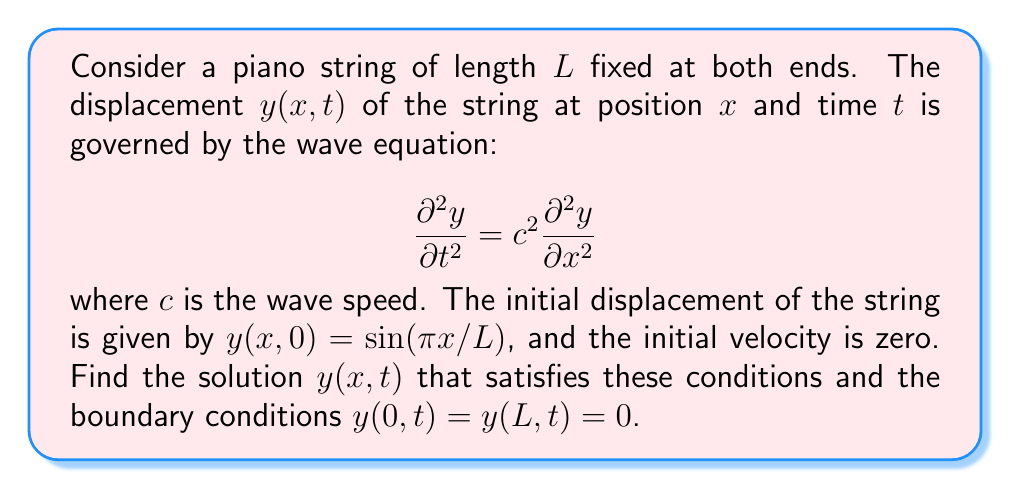Solve this math problem. 1) We start by assuming a solution of the form:
   $$y(x,t) = X(x)T(t)$$

2) Substituting this into the wave equation:
   $$X(x)T''(t) = c^2X''(x)T(t)$$

3) Separating variables:
   $$\frac{T''(t)}{c^2T(t)} = \frac{X''(x)}{X(x)} = -k^2$$

4) This gives us two equations:
   $$X''(x) + k^2X(x) = 0$$
   $$T''(t) + c^2k^2T(t) = 0$$

5) Solving for $X(x)$ with boundary conditions:
   $$X(x) = A\sin(kx)$$
   $$k = \frac{n\pi}{L}, n = 1,2,3,...$$

6) Solving for $T(t)$:
   $$T(t) = B\cos(\omega t) + C\sin(\omega t)$$
   where $\omega = ck = \frac{cn\pi}{L}$

7) The general solution is:
   $$y(x,t) = \sum_{n=1}^{\infty} (B_n\cos(\omega_n t) + C_n\sin(\omega_n t))\sin(\frac{n\pi x}{L})$$

8) Applying initial conditions:
   $y(x,0) = \sin(\pi x/L)$, so $B_1 = 1$ and $B_n = 0$ for $n > 1$
   $\frac{\partial y}{\partial t}(x,0) = 0$, so $C_n = 0$ for all $n$

9) Therefore, the final solution is:
   $$y(x,t) = \cos(\frac{c\pi t}{L})\sin(\frac{\pi x}{L})$$
Answer: $y(x,t) = \cos(\frac{c\pi t}{L})\sin(\frac{\pi x}{L})$ 